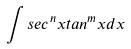<formula> <loc_0><loc_0><loc_500><loc_500>\int s e c ^ { n } x t a n ^ { m } x d x</formula> 